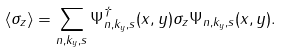<formula> <loc_0><loc_0><loc_500><loc_500>\langle \sigma _ { z } \rangle = \sum _ { n , k _ { y } , s } \Psi _ { n , k _ { y } , s } ^ { \dagger } ( x , y ) \sigma _ { z } \Psi _ { n , k _ { y } , s } ( x , y ) .</formula> 